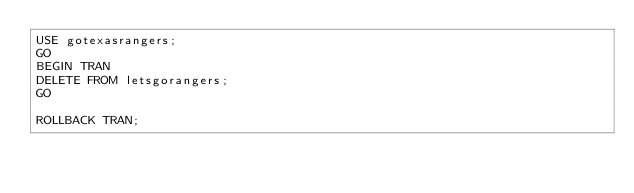Convert code to text. <code><loc_0><loc_0><loc_500><loc_500><_SQL_>USE gotexasrangers;
GO
BEGIN TRAN
DELETE FROM letsgorangers;
GO

ROLLBACK TRAN;</code> 